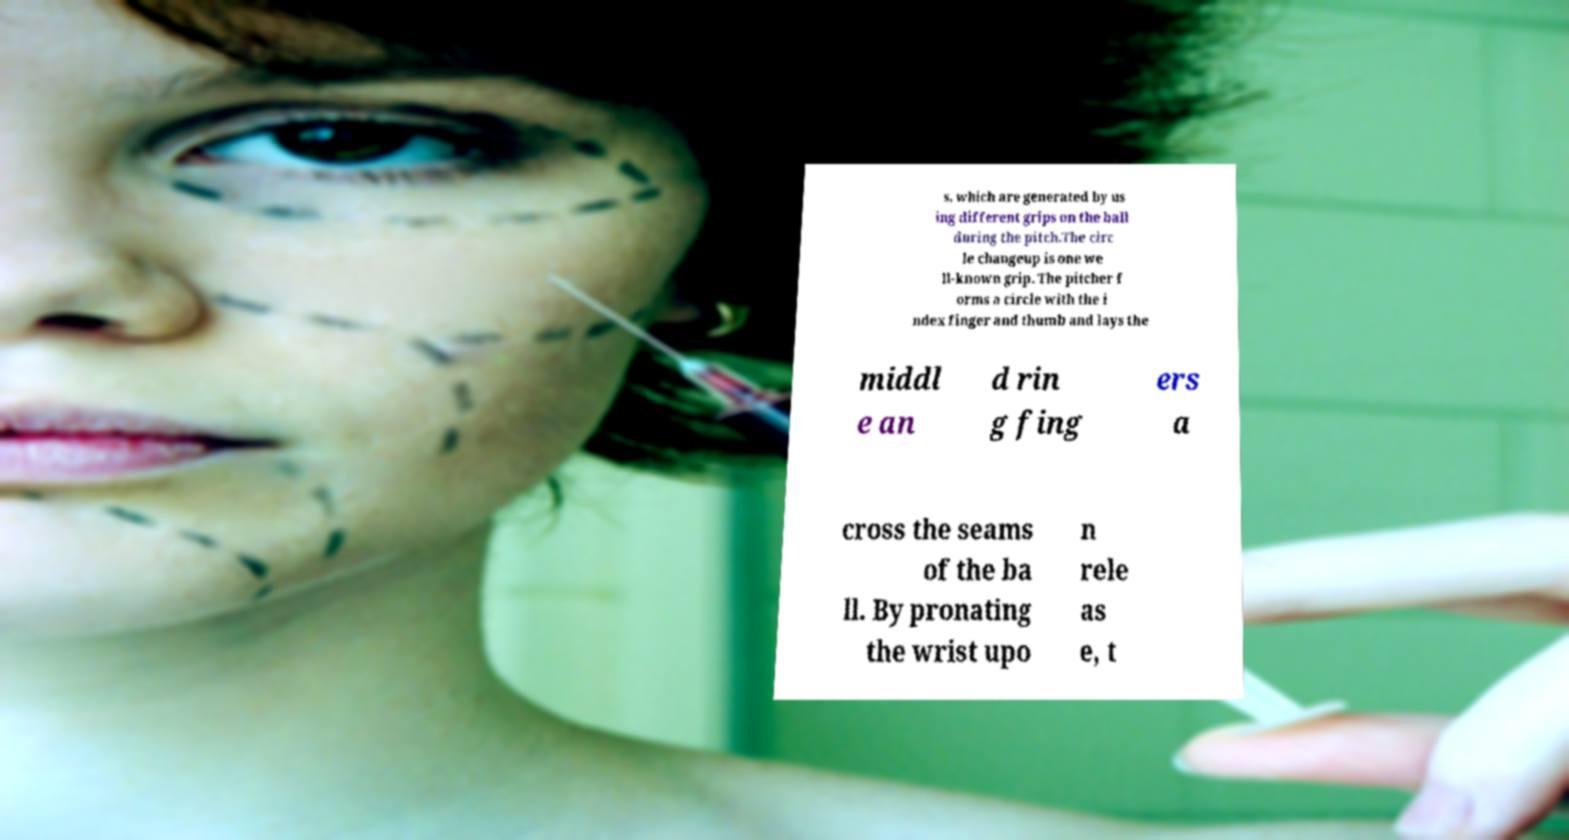Please read and relay the text visible in this image. What does it say? s, which are generated by us ing different grips on the ball during the pitch.The circ le changeup is one we ll-known grip. The pitcher f orms a circle with the i ndex finger and thumb and lays the middl e an d rin g fing ers a cross the seams of the ba ll. By pronating the wrist upo n rele as e, t 